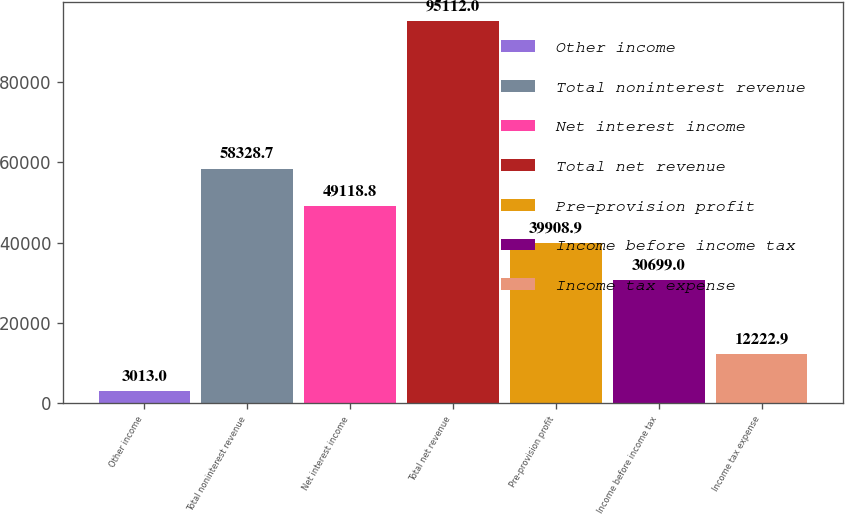<chart> <loc_0><loc_0><loc_500><loc_500><bar_chart><fcel>Other income<fcel>Total noninterest revenue<fcel>Net interest income<fcel>Total net revenue<fcel>Pre-provision profit<fcel>Income before income tax<fcel>Income tax expense<nl><fcel>3013<fcel>58328.7<fcel>49118.8<fcel>95112<fcel>39908.9<fcel>30699<fcel>12222.9<nl></chart> 